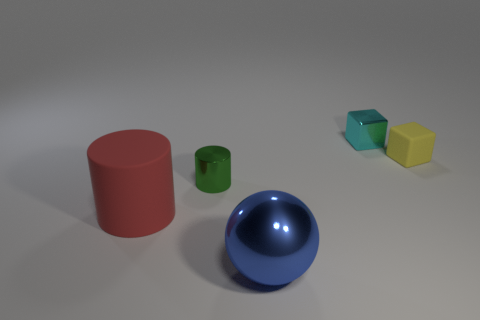Add 5 small green metallic objects. How many objects exist? 10 Subtract all cylinders. How many objects are left? 3 Add 4 green metallic cylinders. How many green metallic cylinders are left? 5 Add 5 small rubber balls. How many small rubber balls exist? 5 Subtract 0 red blocks. How many objects are left? 5 Subtract all big red rubber things. Subtract all cyan metal objects. How many objects are left? 3 